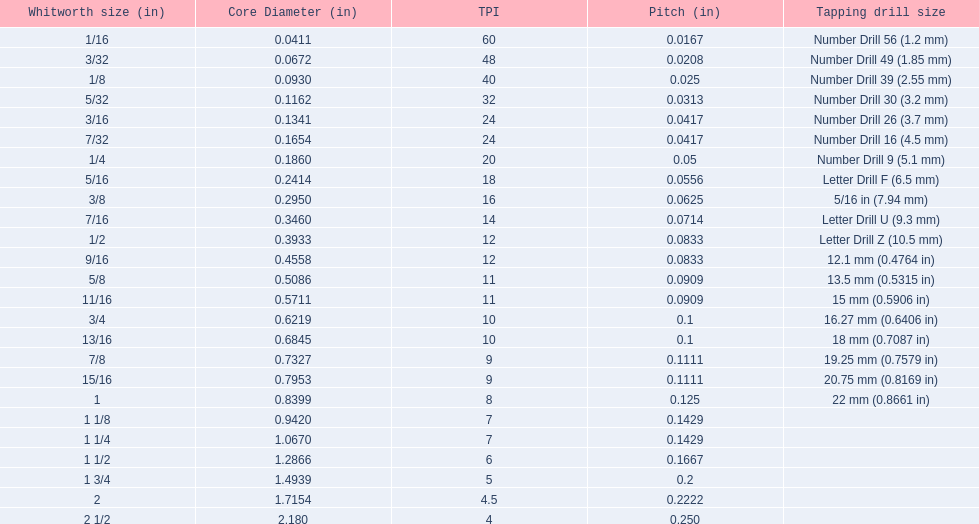What are the sizes of threads per inch? 60, 48, 40, 32, 24, 24, 20, 18, 16, 14, 12, 12, 11, 11, 10, 10, 9, 9, 8, 7, 7, 6, 5, 4.5, 4. Which whitworth size has only 5 threads per inch? 1 3/4. 